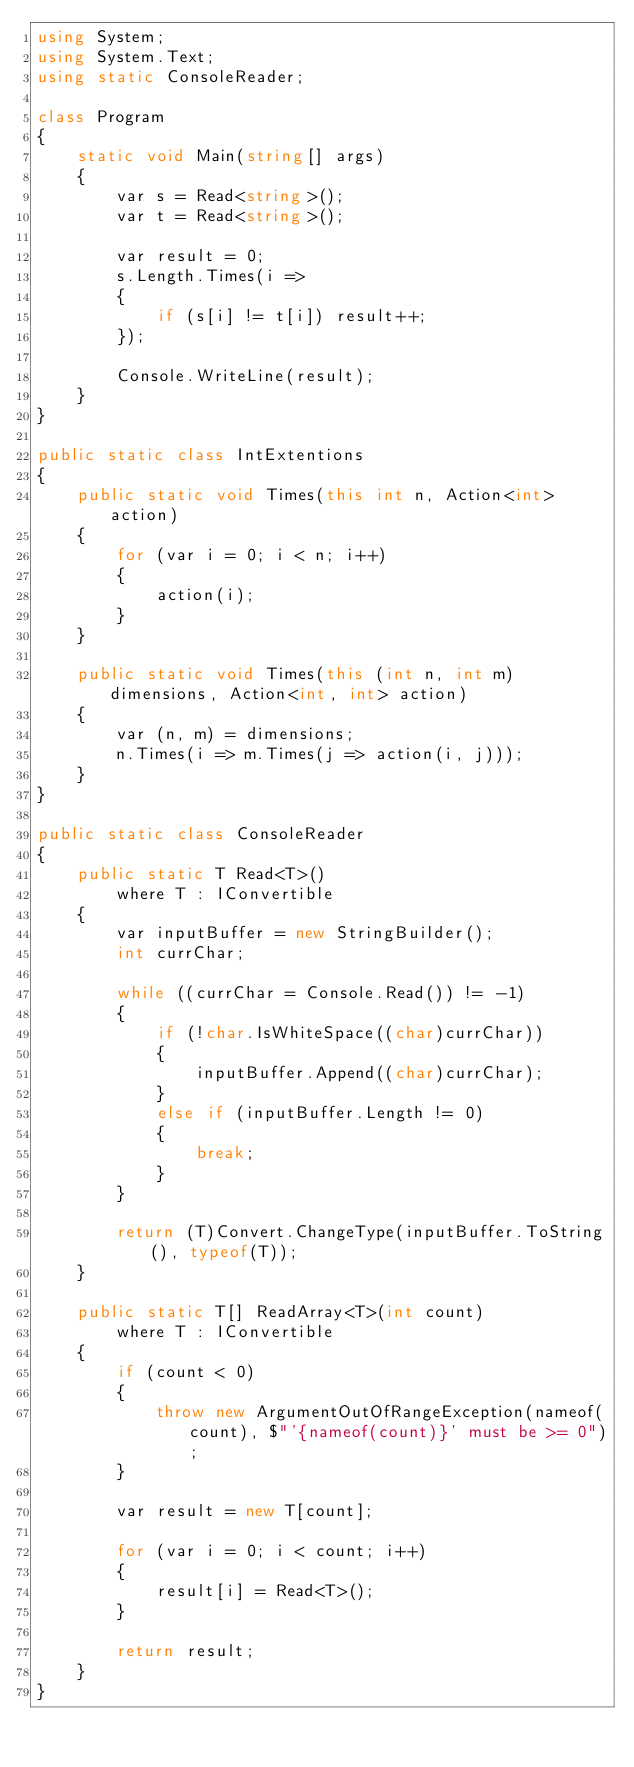<code> <loc_0><loc_0><loc_500><loc_500><_C#_>using System;
using System.Text;
using static ConsoleReader;

class Program
{
    static void Main(string[] args)
    {
        var s = Read<string>();
        var t = Read<string>();

        var result = 0;
        s.Length.Times(i =>
        {
            if (s[i] != t[i]) result++;
        });

        Console.WriteLine(result);
    }
}

public static class IntExtentions
{
    public static void Times(this int n, Action<int> action)
    {
        for (var i = 0; i < n; i++)
        {
            action(i);
        }
    }

    public static void Times(this (int n, int m) dimensions, Action<int, int> action)
    {
        var (n, m) = dimensions;
        n.Times(i => m.Times(j => action(i, j)));
    }
}

public static class ConsoleReader
{
    public static T Read<T>()
        where T : IConvertible
    {
        var inputBuffer = new StringBuilder();
        int currChar;

        while ((currChar = Console.Read()) != -1)
        {
            if (!char.IsWhiteSpace((char)currChar))
            {
                inputBuffer.Append((char)currChar);
            }
            else if (inputBuffer.Length != 0)
            {
                break;
            }
        }

        return (T)Convert.ChangeType(inputBuffer.ToString(), typeof(T));
    }

    public static T[] ReadArray<T>(int count)
        where T : IConvertible
    {
        if (count < 0)
        {
            throw new ArgumentOutOfRangeException(nameof(count), $"'{nameof(count)}' must be >= 0");
        }

        var result = new T[count];

        for (var i = 0; i < count; i++)
        {
            result[i] = Read<T>();
        }

        return result;
    }
}</code> 